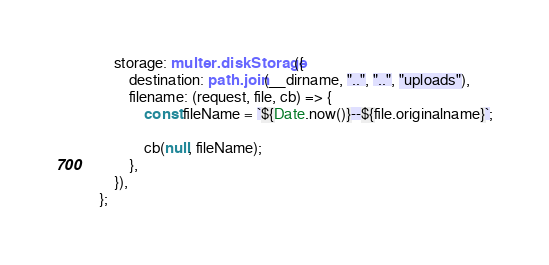Convert code to text. <code><loc_0><loc_0><loc_500><loc_500><_TypeScript_>	storage: multer.diskStorage({
		destination: path.join(__dirname, "..", "..", "uploads"),
		filename: (request, file, cb) => {
			const fileName = `${Date.now()}--${file.originalname}`;

			cb(null, fileName);
		},
	}),
};
</code> 